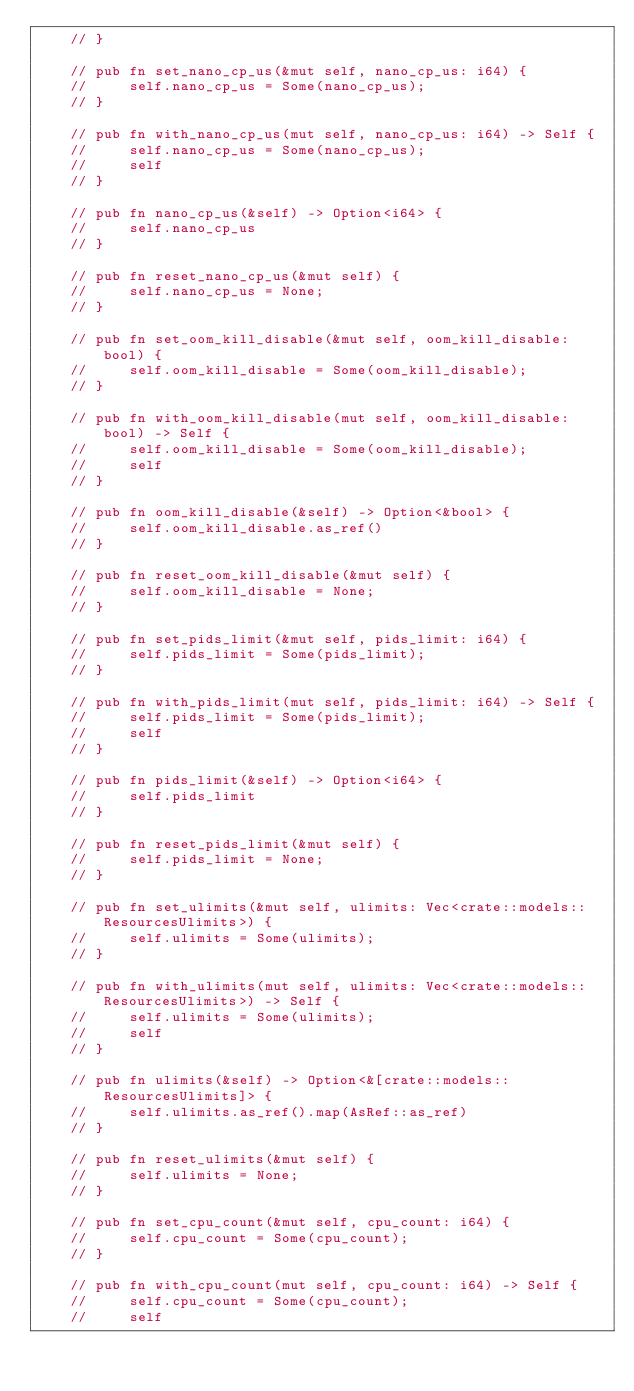<code> <loc_0><loc_0><loc_500><loc_500><_Rust_>    // }

    // pub fn set_nano_cp_us(&mut self, nano_cp_us: i64) {
    //     self.nano_cp_us = Some(nano_cp_us);
    // }

    // pub fn with_nano_cp_us(mut self, nano_cp_us: i64) -> Self {
    //     self.nano_cp_us = Some(nano_cp_us);
    //     self
    // }

    // pub fn nano_cp_us(&self) -> Option<i64> {
    //     self.nano_cp_us
    // }

    // pub fn reset_nano_cp_us(&mut self) {
    //     self.nano_cp_us = None;
    // }

    // pub fn set_oom_kill_disable(&mut self, oom_kill_disable: bool) {
    //     self.oom_kill_disable = Some(oom_kill_disable);
    // }

    // pub fn with_oom_kill_disable(mut self, oom_kill_disable: bool) -> Self {
    //     self.oom_kill_disable = Some(oom_kill_disable);
    //     self
    // }

    // pub fn oom_kill_disable(&self) -> Option<&bool> {
    //     self.oom_kill_disable.as_ref()
    // }

    // pub fn reset_oom_kill_disable(&mut self) {
    //     self.oom_kill_disable = None;
    // }

    // pub fn set_pids_limit(&mut self, pids_limit: i64) {
    //     self.pids_limit = Some(pids_limit);
    // }

    // pub fn with_pids_limit(mut self, pids_limit: i64) -> Self {
    //     self.pids_limit = Some(pids_limit);
    //     self
    // }

    // pub fn pids_limit(&self) -> Option<i64> {
    //     self.pids_limit
    // }

    // pub fn reset_pids_limit(&mut self) {
    //     self.pids_limit = None;
    // }

    // pub fn set_ulimits(&mut self, ulimits: Vec<crate::models::ResourcesUlimits>) {
    //     self.ulimits = Some(ulimits);
    // }

    // pub fn with_ulimits(mut self, ulimits: Vec<crate::models::ResourcesUlimits>) -> Self {
    //     self.ulimits = Some(ulimits);
    //     self
    // }

    // pub fn ulimits(&self) -> Option<&[crate::models::ResourcesUlimits]> {
    //     self.ulimits.as_ref().map(AsRef::as_ref)
    // }

    // pub fn reset_ulimits(&mut self) {
    //     self.ulimits = None;
    // }

    // pub fn set_cpu_count(&mut self, cpu_count: i64) {
    //     self.cpu_count = Some(cpu_count);
    // }

    // pub fn with_cpu_count(mut self, cpu_count: i64) -> Self {
    //     self.cpu_count = Some(cpu_count);
    //     self</code> 